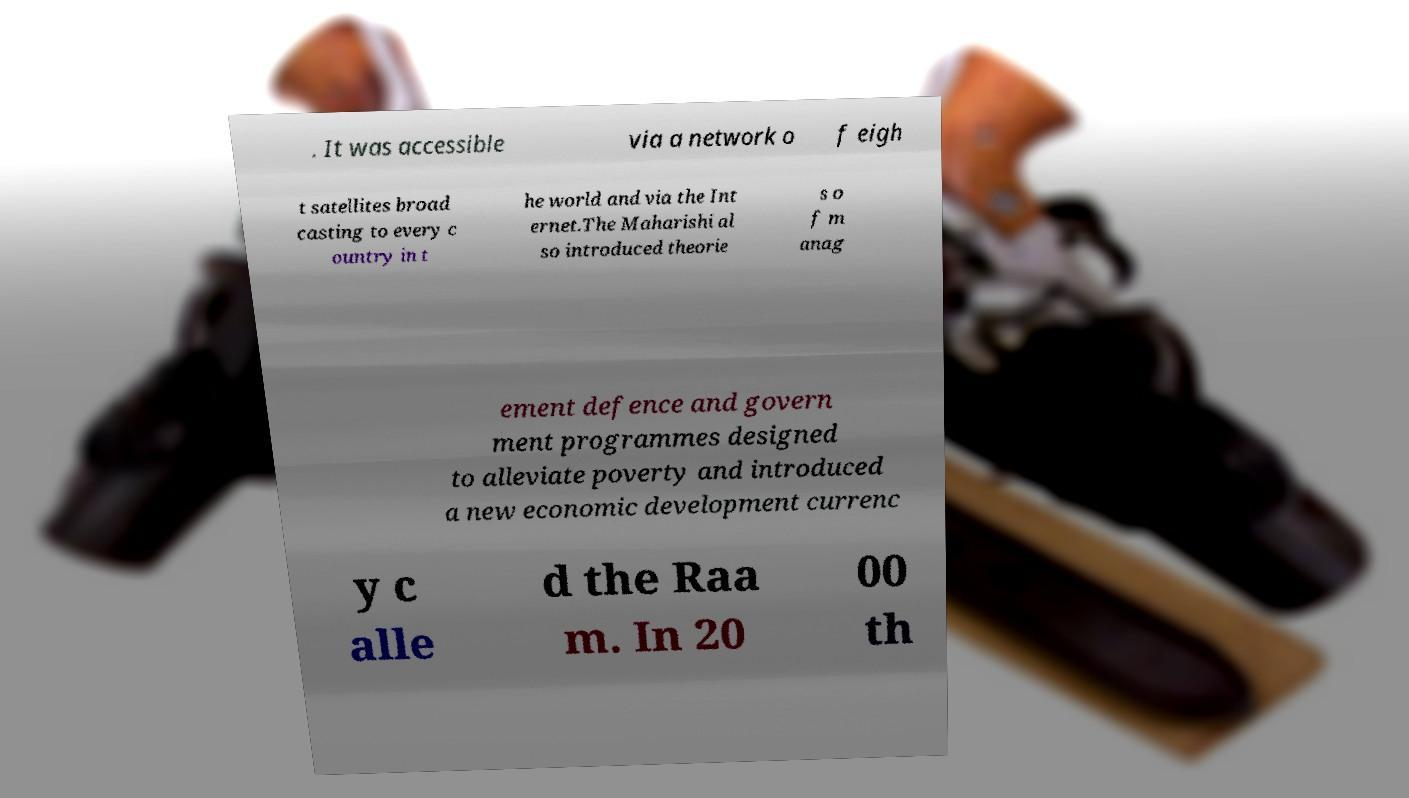Please read and relay the text visible in this image. What does it say? . It was accessible via a network o f eigh t satellites broad casting to every c ountry in t he world and via the Int ernet.The Maharishi al so introduced theorie s o f m anag ement defence and govern ment programmes designed to alleviate poverty and introduced a new economic development currenc y c alle d the Raa m. In 20 00 th 